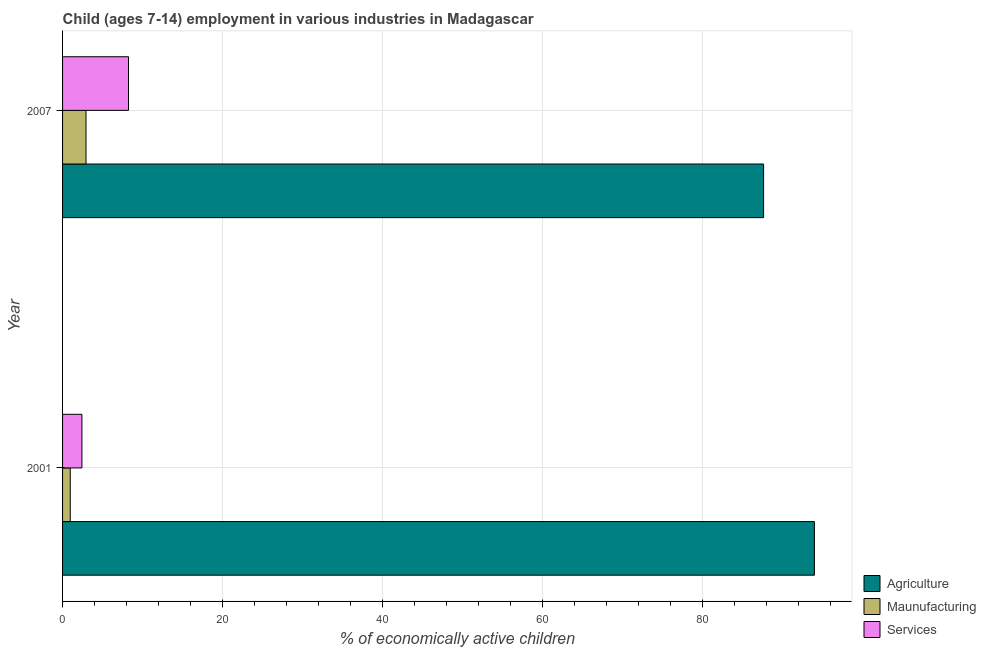How many different coloured bars are there?
Your answer should be compact. 3. Are the number of bars per tick equal to the number of legend labels?
Ensure brevity in your answer.  Yes. Are the number of bars on each tick of the Y-axis equal?
Your answer should be compact. Yes. How many bars are there on the 2nd tick from the top?
Offer a very short reply. 3. How many bars are there on the 2nd tick from the bottom?
Provide a succinct answer. 3. In how many cases, is the number of bars for a given year not equal to the number of legend labels?
Ensure brevity in your answer.  0. What is the percentage of economically active children in manufacturing in 2001?
Your answer should be compact. 0.96. Across all years, what is the maximum percentage of economically active children in services?
Your response must be concise. 8.24. What is the total percentage of economically active children in services in the graph?
Provide a succinct answer. 10.66. What is the difference between the percentage of economically active children in manufacturing in 2001 and that in 2007?
Ensure brevity in your answer.  -1.97. What is the difference between the percentage of economically active children in agriculture in 2001 and the percentage of economically active children in services in 2007?
Keep it short and to the point. 85.73. What is the average percentage of economically active children in agriculture per year?
Provide a succinct answer. 90.8. In the year 2007, what is the difference between the percentage of economically active children in services and percentage of economically active children in manufacturing?
Provide a succinct answer. 5.31. In how many years, is the percentage of economically active children in manufacturing greater than 84 %?
Your answer should be very brief. 0. What is the ratio of the percentage of economically active children in manufacturing in 2001 to that in 2007?
Your response must be concise. 0.33. Is the percentage of economically active children in agriculture in 2001 less than that in 2007?
Make the answer very short. No. What does the 1st bar from the top in 2001 represents?
Make the answer very short. Services. What does the 3rd bar from the bottom in 2007 represents?
Give a very brief answer. Services. Is it the case that in every year, the sum of the percentage of economically active children in agriculture and percentage of economically active children in manufacturing is greater than the percentage of economically active children in services?
Provide a short and direct response. Yes. Are the values on the major ticks of X-axis written in scientific E-notation?
Provide a succinct answer. No. Where does the legend appear in the graph?
Your answer should be very brief. Bottom right. How many legend labels are there?
Your answer should be very brief. 3. What is the title of the graph?
Your answer should be compact. Child (ages 7-14) employment in various industries in Madagascar. Does "Transport" appear as one of the legend labels in the graph?
Provide a short and direct response. No. What is the label or title of the X-axis?
Make the answer very short. % of economically active children. What is the % of economically active children in Agriculture in 2001?
Keep it short and to the point. 93.97. What is the % of economically active children of Services in 2001?
Ensure brevity in your answer.  2.42. What is the % of economically active children in Agriculture in 2007?
Provide a succinct answer. 87.62. What is the % of economically active children of Maunufacturing in 2007?
Provide a succinct answer. 2.93. What is the % of economically active children of Services in 2007?
Give a very brief answer. 8.24. Across all years, what is the maximum % of economically active children in Agriculture?
Offer a terse response. 93.97. Across all years, what is the maximum % of economically active children of Maunufacturing?
Offer a very short reply. 2.93. Across all years, what is the maximum % of economically active children in Services?
Offer a very short reply. 8.24. Across all years, what is the minimum % of economically active children of Agriculture?
Keep it short and to the point. 87.62. Across all years, what is the minimum % of economically active children in Services?
Provide a succinct answer. 2.42. What is the total % of economically active children of Agriculture in the graph?
Make the answer very short. 181.59. What is the total % of economically active children in Maunufacturing in the graph?
Ensure brevity in your answer.  3.89. What is the total % of economically active children of Services in the graph?
Your answer should be very brief. 10.66. What is the difference between the % of economically active children of Agriculture in 2001 and that in 2007?
Your answer should be very brief. 6.35. What is the difference between the % of economically active children in Maunufacturing in 2001 and that in 2007?
Your answer should be very brief. -1.97. What is the difference between the % of economically active children of Services in 2001 and that in 2007?
Your response must be concise. -5.82. What is the difference between the % of economically active children in Agriculture in 2001 and the % of economically active children in Maunufacturing in 2007?
Keep it short and to the point. 91.04. What is the difference between the % of economically active children of Agriculture in 2001 and the % of economically active children of Services in 2007?
Keep it short and to the point. 85.73. What is the difference between the % of economically active children in Maunufacturing in 2001 and the % of economically active children in Services in 2007?
Provide a succinct answer. -7.28. What is the average % of economically active children in Agriculture per year?
Keep it short and to the point. 90.8. What is the average % of economically active children in Maunufacturing per year?
Offer a very short reply. 1.95. What is the average % of economically active children of Services per year?
Provide a short and direct response. 5.33. In the year 2001, what is the difference between the % of economically active children in Agriculture and % of economically active children in Maunufacturing?
Your answer should be compact. 93.01. In the year 2001, what is the difference between the % of economically active children in Agriculture and % of economically active children in Services?
Your response must be concise. 91.55. In the year 2001, what is the difference between the % of economically active children of Maunufacturing and % of economically active children of Services?
Provide a succinct answer. -1.46. In the year 2007, what is the difference between the % of economically active children in Agriculture and % of economically active children in Maunufacturing?
Offer a very short reply. 84.69. In the year 2007, what is the difference between the % of economically active children of Agriculture and % of economically active children of Services?
Your answer should be compact. 79.38. In the year 2007, what is the difference between the % of economically active children in Maunufacturing and % of economically active children in Services?
Offer a very short reply. -5.31. What is the ratio of the % of economically active children in Agriculture in 2001 to that in 2007?
Ensure brevity in your answer.  1.07. What is the ratio of the % of economically active children in Maunufacturing in 2001 to that in 2007?
Your response must be concise. 0.33. What is the ratio of the % of economically active children of Services in 2001 to that in 2007?
Your answer should be very brief. 0.29. What is the difference between the highest and the second highest % of economically active children of Agriculture?
Keep it short and to the point. 6.35. What is the difference between the highest and the second highest % of economically active children in Maunufacturing?
Keep it short and to the point. 1.97. What is the difference between the highest and the second highest % of economically active children in Services?
Your answer should be compact. 5.82. What is the difference between the highest and the lowest % of economically active children of Agriculture?
Your response must be concise. 6.35. What is the difference between the highest and the lowest % of economically active children in Maunufacturing?
Offer a very short reply. 1.97. What is the difference between the highest and the lowest % of economically active children of Services?
Offer a very short reply. 5.82. 